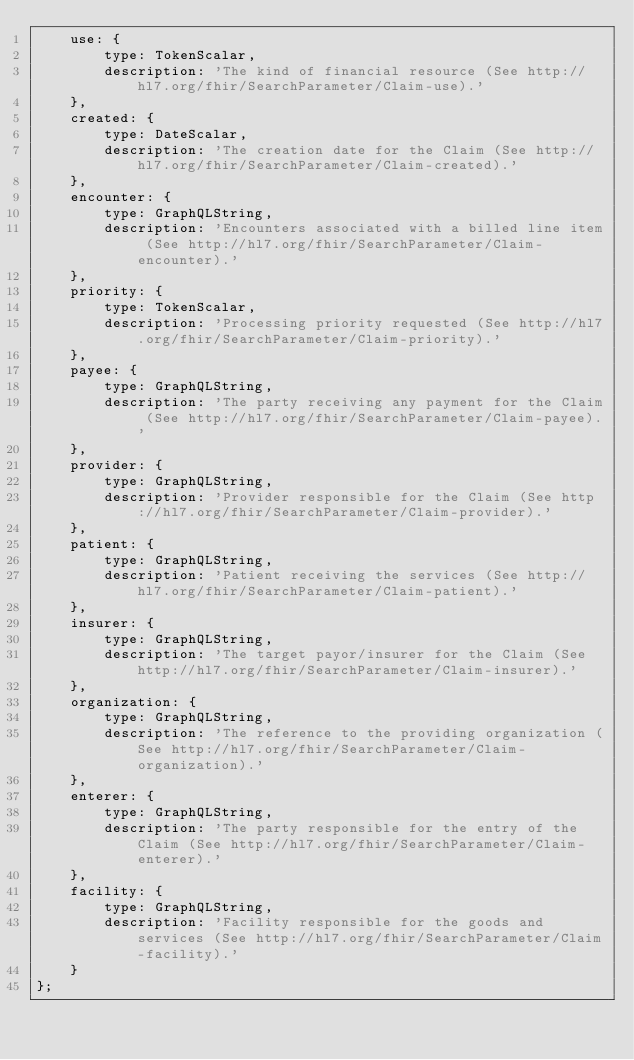<code> <loc_0><loc_0><loc_500><loc_500><_JavaScript_>	use: {
		type: TokenScalar,
		description: 'The kind of financial resource (See http://hl7.org/fhir/SearchParameter/Claim-use).'
	},
	created: {
		type: DateScalar,
		description: 'The creation date for the Claim (See http://hl7.org/fhir/SearchParameter/Claim-created).'
	},
	encounter: {
		type: GraphQLString,
		description: 'Encounters associated with a billed line item (See http://hl7.org/fhir/SearchParameter/Claim-encounter).'
	},
	priority: {
		type: TokenScalar,
		description: 'Processing priority requested (See http://hl7.org/fhir/SearchParameter/Claim-priority).'
	},
	payee: {
		type: GraphQLString,
		description: 'The party receiving any payment for the Claim (See http://hl7.org/fhir/SearchParameter/Claim-payee).'
	},
	provider: {
		type: GraphQLString,
		description: 'Provider responsible for the Claim (See http://hl7.org/fhir/SearchParameter/Claim-provider).'
	},
	patient: {
		type: GraphQLString,
		description: 'Patient receiving the services (See http://hl7.org/fhir/SearchParameter/Claim-patient).'
	},
	insurer: {
		type: GraphQLString,
		description: 'The target payor/insurer for the Claim (See http://hl7.org/fhir/SearchParameter/Claim-insurer).'
	},
	organization: {
		type: GraphQLString,
		description: 'The reference to the providing organization (See http://hl7.org/fhir/SearchParameter/Claim-organization).'
	},
	enterer: {
		type: GraphQLString,
		description: 'The party responsible for the entry of the Claim (See http://hl7.org/fhir/SearchParameter/Claim-enterer).'
	},
	facility: {
		type: GraphQLString,
		description: 'Facility responsible for the goods and services (See http://hl7.org/fhir/SearchParameter/Claim-facility).'
	}
};
</code> 